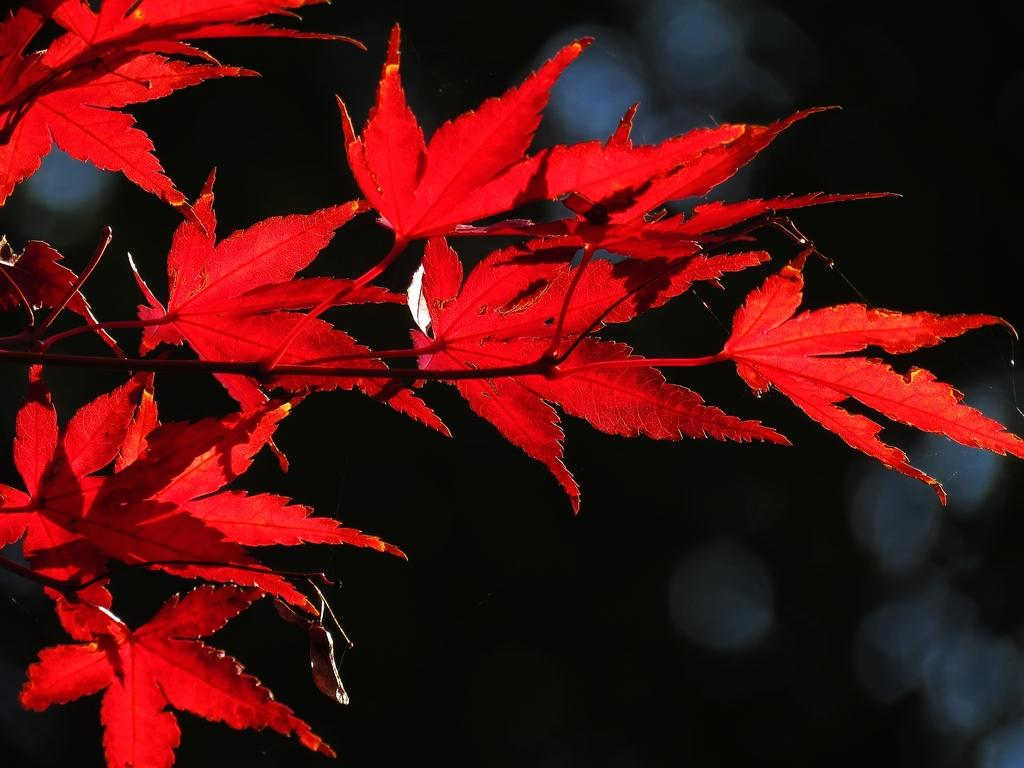What is the main object in the image? There is a tree in the image. Can you describe the lighting conditions in the image? The image appears to be dark, possibly taken during nighttime. What type of current can be seen flowing through the tree in the image? There is no current flowing through the tree in the image, as it is a static photograph. 